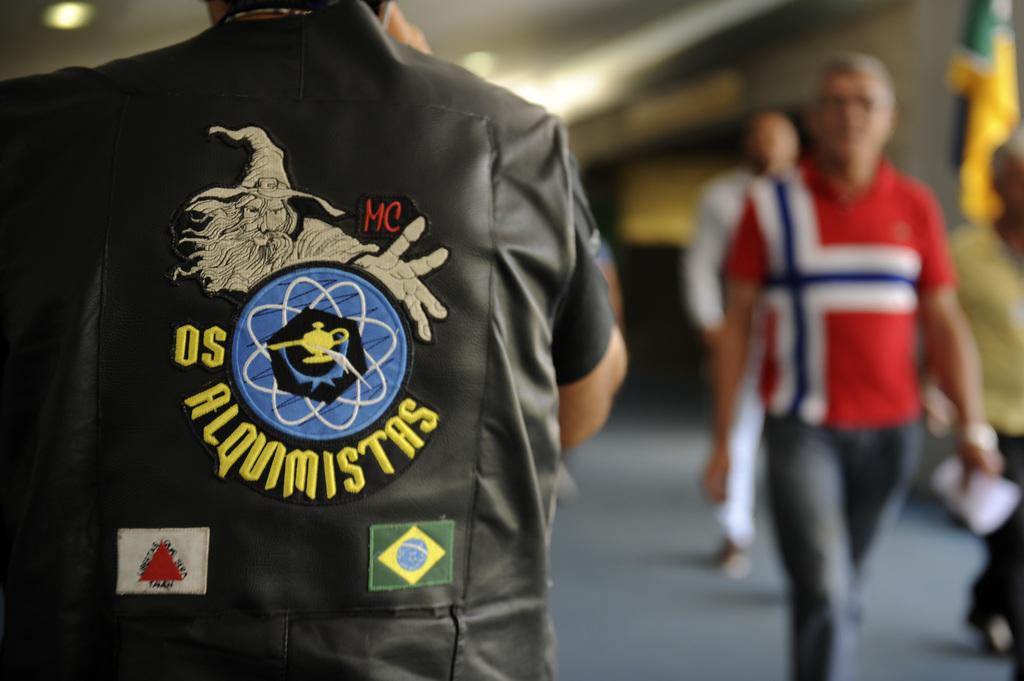What does his jacket say?
Your response must be concise. Alquimistas. 